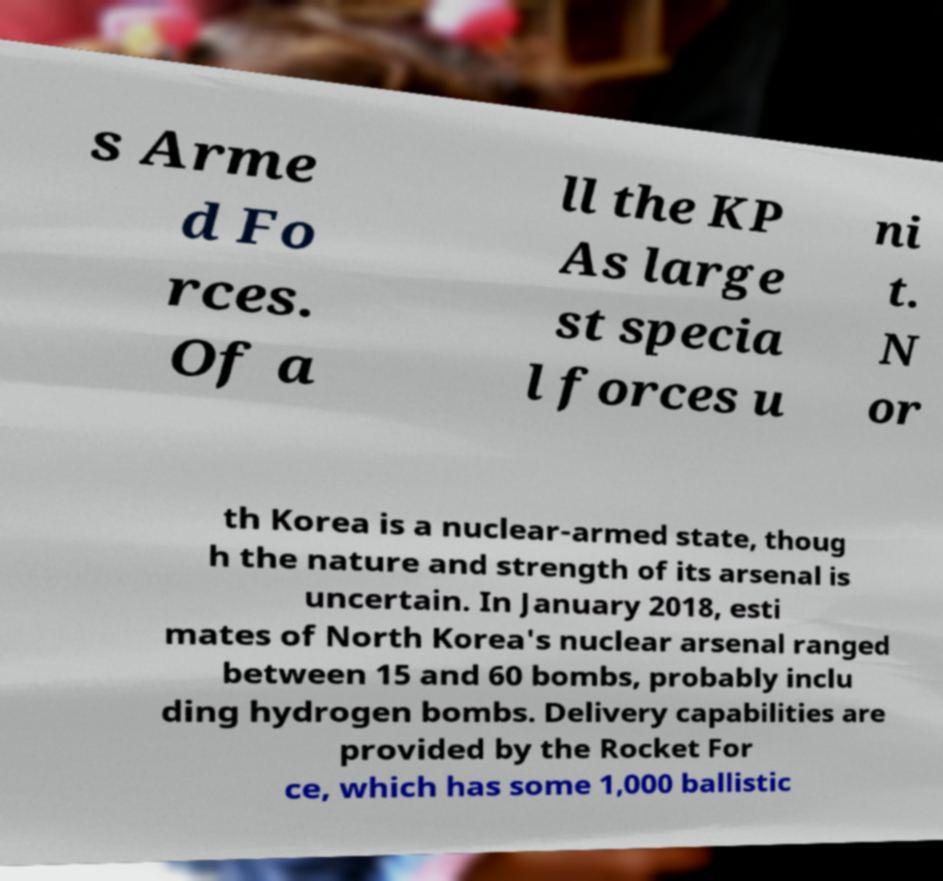Can you read and provide the text displayed in the image?This photo seems to have some interesting text. Can you extract and type it out for me? s Arme d Fo rces. Of a ll the KP As large st specia l forces u ni t. N or th Korea is a nuclear-armed state, thoug h the nature and strength of its arsenal is uncertain. In January 2018, esti mates of North Korea's nuclear arsenal ranged between 15 and 60 bombs, probably inclu ding hydrogen bombs. Delivery capabilities are provided by the Rocket For ce, which has some 1,000 ballistic 